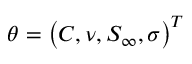Convert formula to latex. <formula><loc_0><loc_0><loc_500><loc_500>\theta = \left ( C , \nu , S _ { \infty } , \sigma \right ) ^ { T }</formula> 